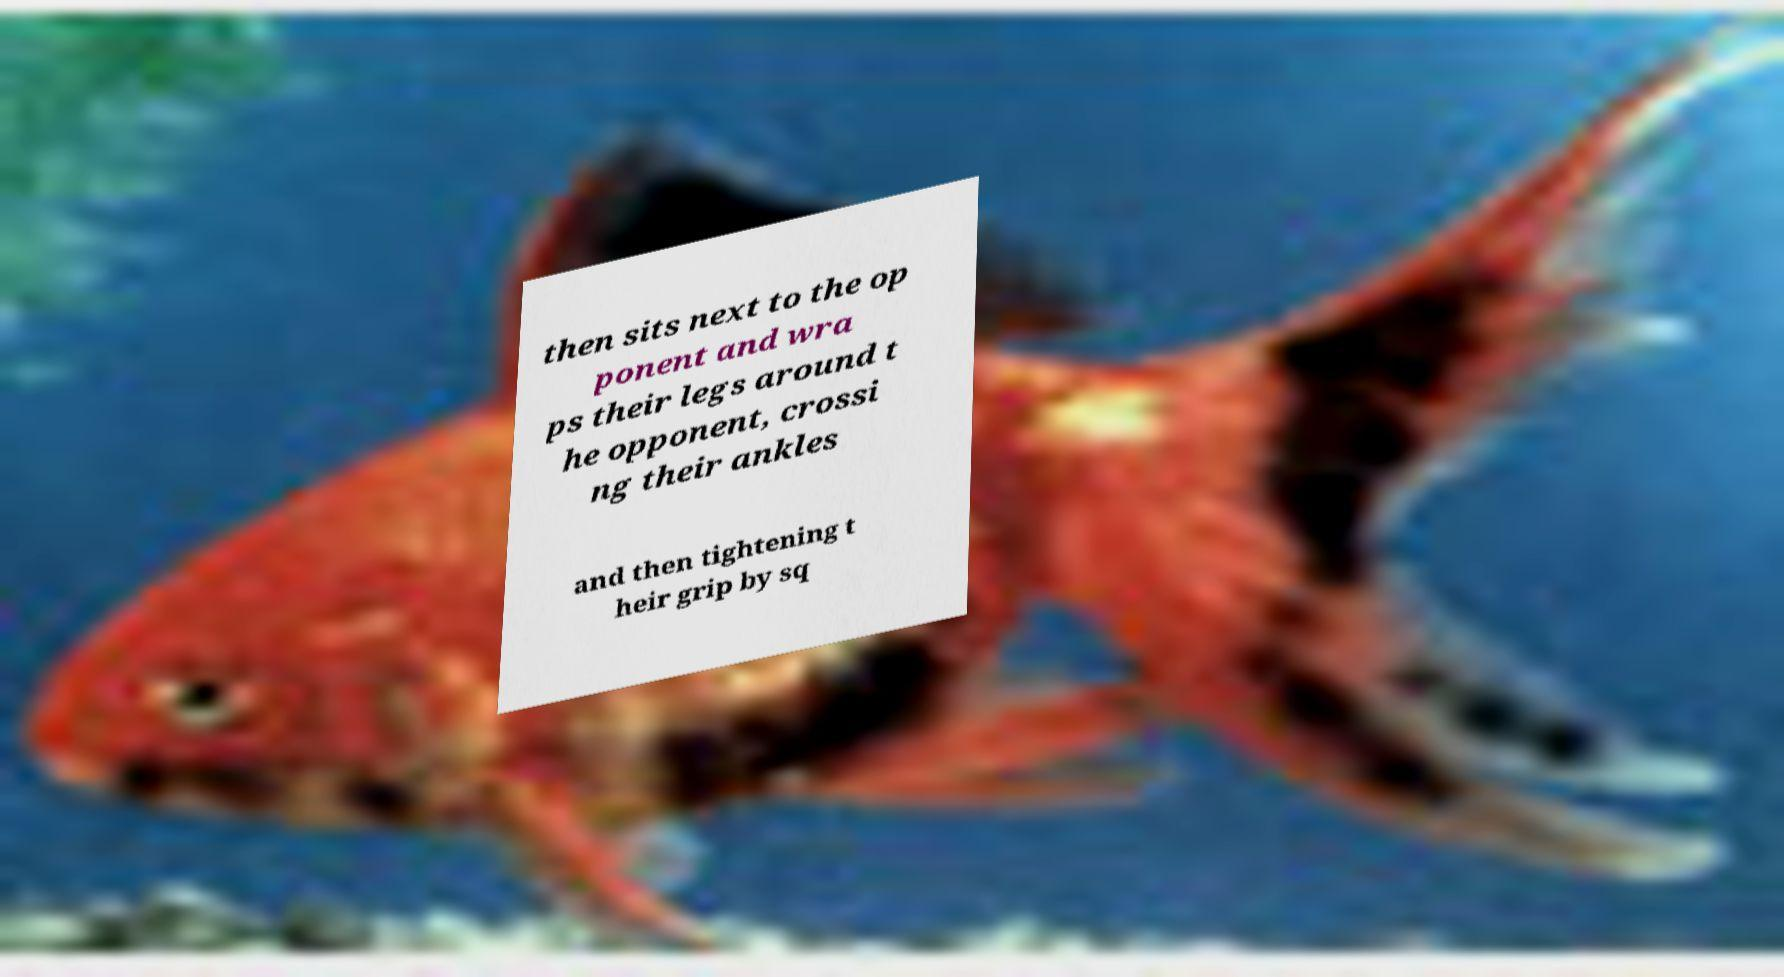Could you extract and type out the text from this image? then sits next to the op ponent and wra ps their legs around t he opponent, crossi ng their ankles and then tightening t heir grip by sq 